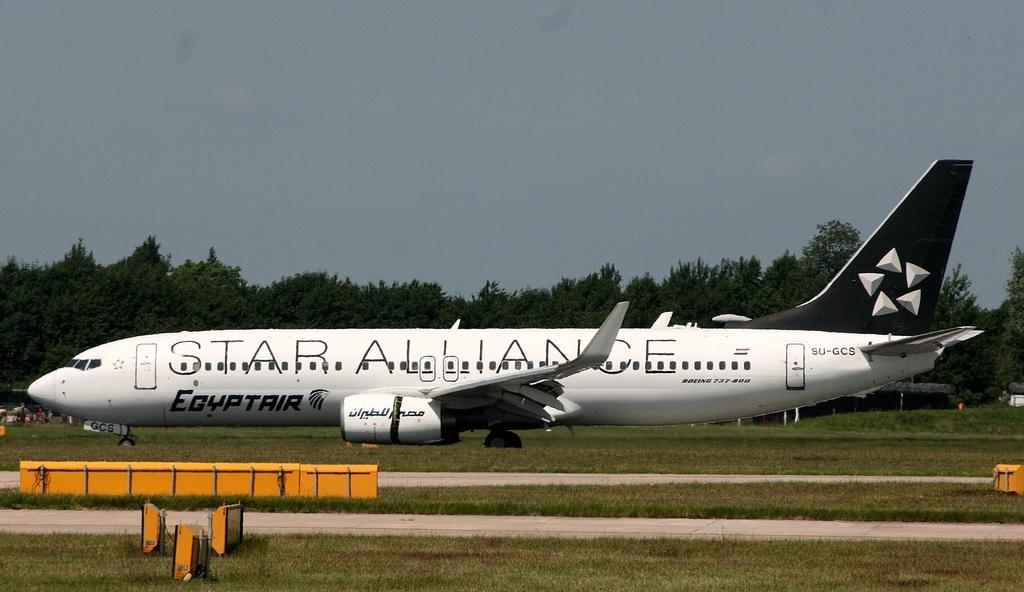What airline is this?
Offer a very short reply. Star alliance. What are the large thin letters on the fuselage?
Provide a short and direct response. Star alliance. 